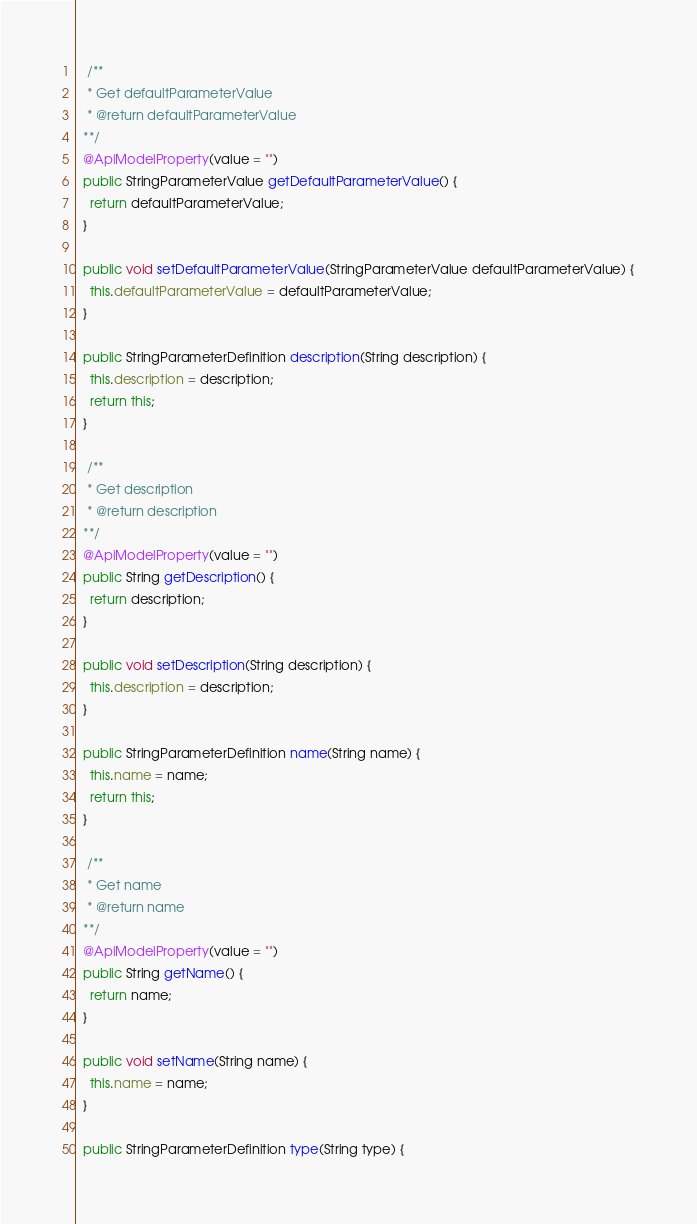Convert code to text. <code><loc_0><loc_0><loc_500><loc_500><_Java_>
   /**
   * Get defaultParameterValue
   * @return defaultParameterValue
  **/
  @ApiModelProperty(value = "")
  public StringParameterValue getDefaultParameterValue() {
    return defaultParameterValue;
  }

  public void setDefaultParameterValue(StringParameterValue defaultParameterValue) {
    this.defaultParameterValue = defaultParameterValue;
  }

  public StringParameterDefinition description(String description) {
    this.description = description;
    return this;
  }

   /**
   * Get description
   * @return description
  **/
  @ApiModelProperty(value = "")
  public String getDescription() {
    return description;
  }

  public void setDescription(String description) {
    this.description = description;
  }

  public StringParameterDefinition name(String name) {
    this.name = name;
    return this;
  }

   /**
   * Get name
   * @return name
  **/
  @ApiModelProperty(value = "")
  public String getName() {
    return name;
  }

  public void setName(String name) {
    this.name = name;
  }

  public StringParameterDefinition type(String type) {</code> 